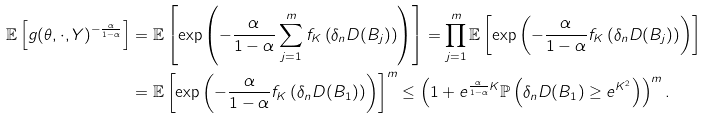<formula> <loc_0><loc_0><loc_500><loc_500>\mathbb { E } \left [ g ( \theta , \cdot , Y ) ^ { - \frac { \alpha } { 1 - \alpha } } \right ] & = \mathbb { E } \left [ \exp \left ( - \frac { \alpha } { 1 - \alpha } \sum _ { j = 1 } ^ { m } f _ { K } \left ( \delta _ { n } D ( B _ { j } ) \right ) \right ) \right ] = \prod _ { j = 1 } ^ { m } \mathbb { E } \left [ \exp \left ( - \frac { \alpha } { 1 - \alpha } f _ { K } \left ( \delta _ { n } D ( B _ { j } ) \right ) \right ) \right ] \\ & = \mathbb { E } \left [ \exp \left ( - \frac { \alpha } { 1 - \alpha } f _ { K } \left ( \delta _ { n } D ( B _ { 1 } ) \right ) \right ) \right ] ^ { m } \leq \left ( 1 + e ^ { \frac { \alpha } { 1 - \alpha } K } \mathbb { P } \left ( \delta _ { n } D ( B _ { 1 } ) \geq e ^ { K ^ { 2 } } \right ) \right ) ^ { m } .</formula> 